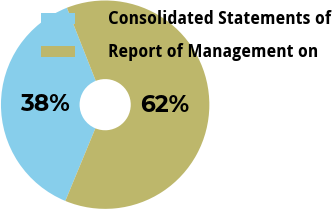Convert chart to OTSL. <chart><loc_0><loc_0><loc_500><loc_500><pie_chart><fcel>Consolidated Statements of<fcel>Report of Management on<nl><fcel>37.78%<fcel>62.22%<nl></chart> 